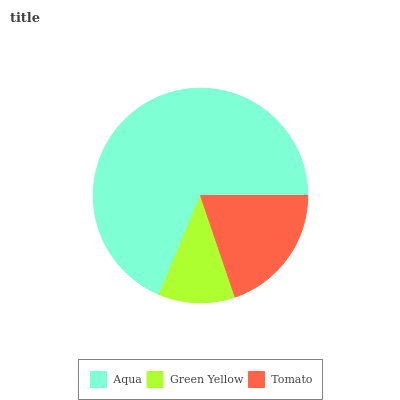Is Green Yellow the minimum?
Answer yes or no. Yes. Is Aqua the maximum?
Answer yes or no. Yes. Is Tomato the minimum?
Answer yes or no. No. Is Tomato the maximum?
Answer yes or no. No. Is Tomato greater than Green Yellow?
Answer yes or no. Yes. Is Green Yellow less than Tomato?
Answer yes or no. Yes. Is Green Yellow greater than Tomato?
Answer yes or no. No. Is Tomato less than Green Yellow?
Answer yes or no. No. Is Tomato the high median?
Answer yes or no. Yes. Is Tomato the low median?
Answer yes or no. Yes. Is Green Yellow the high median?
Answer yes or no. No. Is Aqua the low median?
Answer yes or no. No. 